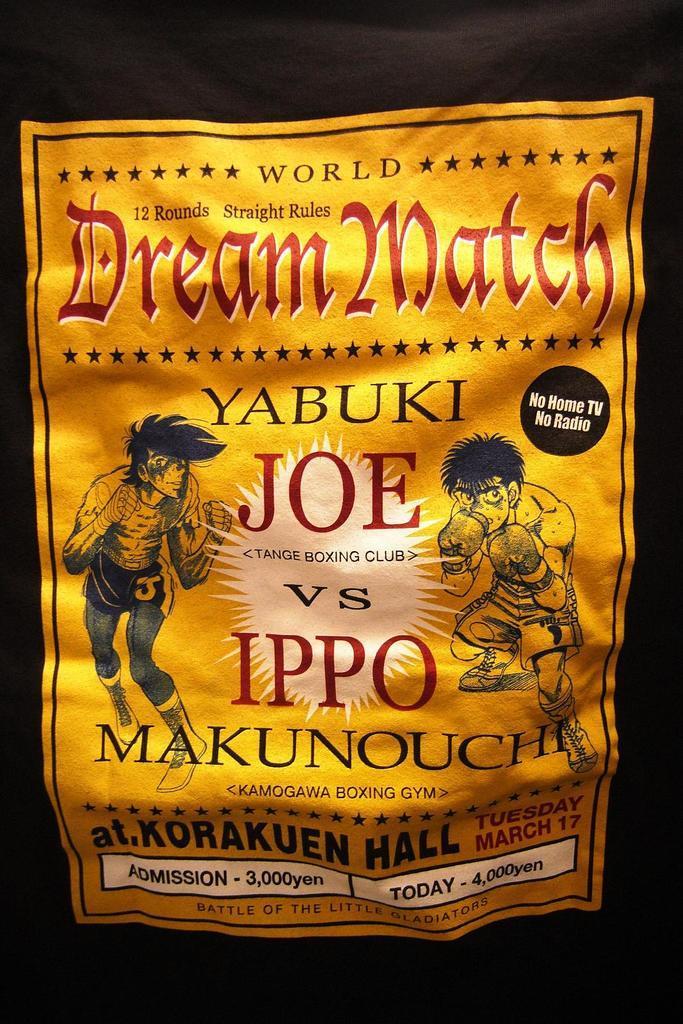In one or two sentences, can you explain what this image depicts? The picture consists of a poster. In the poster there are cartoons of two persons and there is text. 